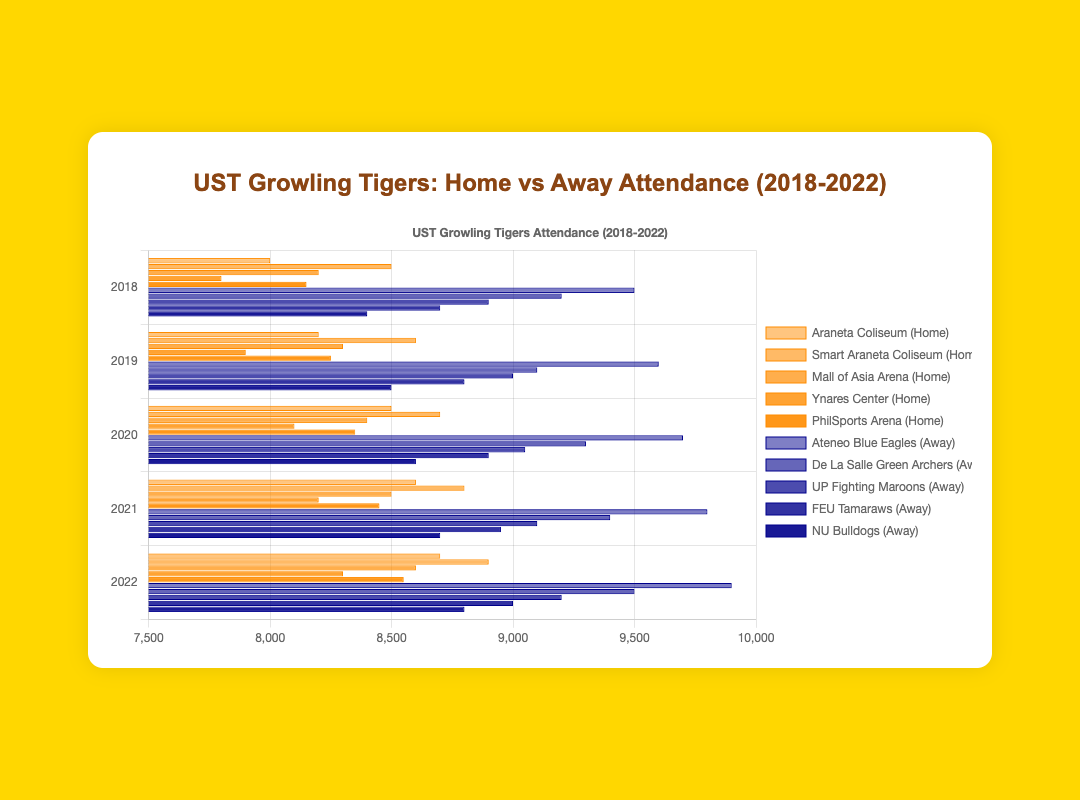Which venue had the highest home attendance in 2022? Look at the year 2022 and find the bar with the highest length in home venues.
Answer: Smart Araneta Coliseum How did the home attendance at the Mall of Asia Arena change from 2018 to 2022? Track the Mall of Asia Arena home attendance across the years from 2018 to 2022 and observe the change: 8200 (2018), 8300 (2019), 8400 (2020), 8500 (2021), 8600 (2022).
Answer: Increased by 400 What was the difference in home attendance at Ynares Center from 2019 to 2021? Subtract the 2019 attendance at Ynares Center (7900) from the 2021 attendance (8200): 8200 - 7900
Answer: 300 Compare the away attendance for Ateneo Blue Eagles and FEU Tamaraws in 2020. Which one had more attendance, and by how much? Compare the lengths of the bars for Ateneo Blue Eagles (9700) and FEU Tamaraws (8900) in 2020. Subtract the attendance figures: 9700 - 8900
Answer: Ateneo Blue Eagles by 800 What is the average home attendance at the Araneta Coliseum over the 5 years? Sum the attendance figures for Araneta Coliseum (8000 + 8200 + 8500 + 8600 + 8700), then divide by 5: (8000 + 8200 + 8500 + 8600 + 8700) / 5
Answer: 8400 Which team had the least away attendance in 2021? Look at the away attendance bars in 2021 and find the shortest one.
Answer: NU Bulldogs Combine the attendance figures of Ynares Center and PhilSports Arena in 2020. What is the total? Add the home attendance values of Ynares Center (8100) and PhilSports Arena (8350) in 2020: 8100 + 8350
Answer: 16450 What is the ratio of home attendance at Smart Araneta Coliseum to Araneta Coliseum in 2019? Divide the Smart Araneta Coliseum attendance (8600) by the Araneta Coliseum attendance (8200) in 2019: 8600 / 8200
Answer: 1.049 How much did the attendance at PhilSports Arena increase from 2018 to 2019? Subtract the 2018 attendance at PhilSports Arena (8150) from the 2019 attendance (8250): 8250 - 8150
Answer: 100 Considering the visual attributes, which venue in 2022 has bars with the highest height difference between home and away games? Observe the bars in 2022 and identify which venue has the most noticeable height difference between the home and away bars.
Answer: Ateneo Blue Eagles 